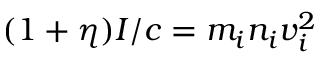Convert formula to latex. <formula><loc_0><loc_0><loc_500><loc_500>( 1 + \eta ) I / c = m _ { i } n _ { i } v _ { i } ^ { 2 }</formula> 